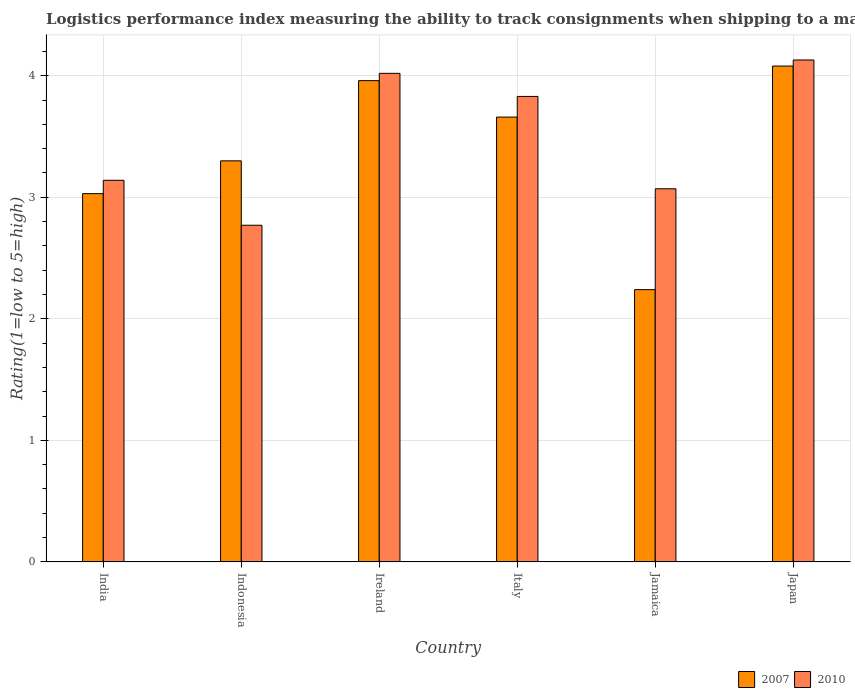How many groups of bars are there?
Keep it short and to the point. 6. What is the label of the 3rd group of bars from the left?
Your response must be concise. Ireland. In how many cases, is the number of bars for a given country not equal to the number of legend labels?
Offer a terse response. 0. What is the Logistic performance index in 2010 in Indonesia?
Keep it short and to the point. 2.77. Across all countries, what is the maximum Logistic performance index in 2007?
Give a very brief answer. 4.08. Across all countries, what is the minimum Logistic performance index in 2010?
Your response must be concise. 2.77. In which country was the Logistic performance index in 2010 minimum?
Make the answer very short. Indonesia. What is the total Logistic performance index in 2007 in the graph?
Ensure brevity in your answer.  20.27. What is the difference between the Logistic performance index in 2010 in Ireland and that in Jamaica?
Provide a short and direct response. 0.95. What is the difference between the Logistic performance index in 2007 in India and the Logistic performance index in 2010 in Japan?
Give a very brief answer. -1.1. What is the average Logistic performance index in 2007 per country?
Make the answer very short. 3.38. What is the difference between the Logistic performance index of/in 2007 and Logistic performance index of/in 2010 in Jamaica?
Your answer should be very brief. -0.83. What is the ratio of the Logistic performance index in 2010 in Italy to that in Jamaica?
Give a very brief answer. 1.25. What is the difference between the highest and the second highest Logistic performance index in 2007?
Your answer should be very brief. -0.3. What is the difference between the highest and the lowest Logistic performance index in 2007?
Make the answer very short. 1.84. In how many countries, is the Logistic performance index in 2010 greater than the average Logistic performance index in 2010 taken over all countries?
Make the answer very short. 3. Is the sum of the Logistic performance index in 2007 in Italy and Japan greater than the maximum Logistic performance index in 2010 across all countries?
Your answer should be compact. Yes. What does the 1st bar from the right in Jamaica represents?
Your answer should be compact. 2010. What is the difference between two consecutive major ticks on the Y-axis?
Your answer should be compact. 1. How many legend labels are there?
Your answer should be compact. 2. How are the legend labels stacked?
Keep it short and to the point. Horizontal. What is the title of the graph?
Make the answer very short. Logistics performance index measuring the ability to track consignments when shipping to a market. Does "1967" appear as one of the legend labels in the graph?
Your answer should be compact. No. What is the label or title of the X-axis?
Make the answer very short. Country. What is the label or title of the Y-axis?
Your response must be concise. Rating(1=low to 5=high). What is the Rating(1=low to 5=high) in 2007 in India?
Provide a short and direct response. 3.03. What is the Rating(1=low to 5=high) in 2010 in India?
Provide a short and direct response. 3.14. What is the Rating(1=low to 5=high) of 2007 in Indonesia?
Your answer should be very brief. 3.3. What is the Rating(1=low to 5=high) in 2010 in Indonesia?
Your answer should be very brief. 2.77. What is the Rating(1=low to 5=high) of 2007 in Ireland?
Offer a very short reply. 3.96. What is the Rating(1=low to 5=high) of 2010 in Ireland?
Your answer should be very brief. 4.02. What is the Rating(1=low to 5=high) in 2007 in Italy?
Ensure brevity in your answer.  3.66. What is the Rating(1=low to 5=high) of 2010 in Italy?
Offer a very short reply. 3.83. What is the Rating(1=low to 5=high) of 2007 in Jamaica?
Keep it short and to the point. 2.24. What is the Rating(1=low to 5=high) in 2010 in Jamaica?
Keep it short and to the point. 3.07. What is the Rating(1=low to 5=high) of 2007 in Japan?
Ensure brevity in your answer.  4.08. What is the Rating(1=low to 5=high) of 2010 in Japan?
Offer a terse response. 4.13. Across all countries, what is the maximum Rating(1=low to 5=high) in 2007?
Provide a succinct answer. 4.08. Across all countries, what is the maximum Rating(1=low to 5=high) of 2010?
Make the answer very short. 4.13. Across all countries, what is the minimum Rating(1=low to 5=high) in 2007?
Offer a very short reply. 2.24. Across all countries, what is the minimum Rating(1=low to 5=high) of 2010?
Your answer should be compact. 2.77. What is the total Rating(1=low to 5=high) of 2007 in the graph?
Ensure brevity in your answer.  20.27. What is the total Rating(1=low to 5=high) in 2010 in the graph?
Your answer should be compact. 20.96. What is the difference between the Rating(1=low to 5=high) of 2007 in India and that in Indonesia?
Ensure brevity in your answer.  -0.27. What is the difference between the Rating(1=low to 5=high) in 2010 in India and that in Indonesia?
Provide a short and direct response. 0.37. What is the difference between the Rating(1=low to 5=high) in 2007 in India and that in Ireland?
Ensure brevity in your answer.  -0.93. What is the difference between the Rating(1=low to 5=high) in 2010 in India and that in Ireland?
Give a very brief answer. -0.88. What is the difference between the Rating(1=low to 5=high) in 2007 in India and that in Italy?
Keep it short and to the point. -0.63. What is the difference between the Rating(1=low to 5=high) in 2010 in India and that in Italy?
Ensure brevity in your answer.  -0.69. What is the difference between the Rating(1=low to 5=high) of 2007 in India and that in Jamaica?
Offer a very short reply. 0.79. What is the difference between the Rating(1=low to 5=high) of 2010 in India and that in Jamaica?
Keep it short and to the point. 0.07. What is the difference between the Rating(1=low to 5=high) in 2007 in India and that in Japan?
Provide a short and direct response. -1.05. What is the difference between the Rating(1=low to 5=high) in 2010 in India and that in Japan?
Your answer should be compact. -0.99. What is the difference between the Rating(1=low to 5=high) of 2007 in Indonesia and that in Ireland?
Your answer should be very brief. -0.66. What is the difference between the Rating(1=low to 5=high) of 2010 in Indonesia and that in Ireland?
Make the answer very short. -1.25. What is the difference between the Rating(1=low to 5=high) of 2007 in Indonesia and that in Italy?
Your answer should be very brief. -0.36. What is the difference between the Rating(1=low to 5=high) of 2010 in Indonesia and that in Italy?
Your answer should be compact. -1.06. What is the difference between the Rating(1=low to 5=high) in 2007 in Indonesia and that in Jamaica?
Make the answer very short. 1.06. What is the difference between the Rating(1=low to 5=high) of 2010 in Indonesia and that in Jamaica?
Provide a short and direct response. -0.3. What is the difference between the Rating(1=low to 5=high) of 2007 in Indonesia and that in Japan?
Ensure brevity in your answer.  -0.78. What is the difference between the Rating(1=low to 5=high) of 2010 in Indonesia and that in Japan?
Provide a succinct answer. -1.36. What is the difference between the Rating(1=low to 5=high) of 2010 in Ireland and that in Italy?
Your response must be concise. 0.19. What is the difference between the Rating(1=low to 5=high) of 2007 in Ireland and that in Jamaica?
Make the answer very short. 1.72. What is the difference between the Rating(1=low to 5=high) of 2010 in Ireland and that in Jamaica?
Ensure brevity in your answer.  0.95. What is the difference between the Rating(1=low to 5=high) in 2007 in Ireland and that in Japan?
Your response must be concise. -0.12. What is the difference between the Rating(1=low to 5=high) of 2010 in Ireland and that in Japan?
Your answer should be compact. -0.11. What is the difference between the Rating(1=low to 5=high) in 2007 in Italy and that in Jamaica?
Make the answer very short. 1.42. What is the difference between the Rating(1=low to 5=high) in 2010 in Italy and that in Jamaica?
Give a very brief answer. 0.76. What is the difference between the Rating(1=low to 5=high) of 2007 in Italy and that in Japan?
Your answer should be very brief. -0.42. What is the difference between the Rating(1=low to 5=high) in 2007 in Jamaica and that in Japan?
Give a very brief answer. -1.84. What is the difference between the Rating(1=low to 5=high) in 2010 in Jamaica and that in Japan?
Ensure brevity in your answer.  -1.06. What is the difference between the Rating(1=low to 5=high) of 2007 in India and the Rating(1=low to 5=high) of 2010 in Indonesia?
Give a very brief answer. 0.26. What is the difference between the Rating(1=low to 5=high) in 2007 in India and the Rating(1=low to 5=high) in 2010 in Ireland?
Keep it short and to the point. -0.99. What is the difference between the Rating(1=low to 5=high) in 2007 in India and the Rating(1=low to 5=high) in 2010 in Italy?
Your answer should be compact. -0.8. What is the difference between the Rating(1=low to 5=high) in 2007 in India and the Rating(1=low to 5=high) in 2010 in Jamaica?
Offer a very short reply. -0.04. What is the difference between the Rating(1=low to 5=high) in 2007 in India and the Rating(1=low to 5=high) in 2010 in Japan?
Provide a short and direct response. -1.1. What is the difference between the Rating(1=low to 5=high) of 2007 in Indonesia and the Rating(1=low to 5=high) of 2010 in Ireland?
Keep it short and to the point. -0.72. What is the difference between the Rating(1=low to 5=high) of 2007 in Indonesia and the Rating(1=low to 5=high) of 2010 in Italy?
Make the answer very short. -0.53. What is the difference between the Rating(1=low to 5=high) in 2007 in Indonesia and the Rating(1=low to 5=high) in 2010 in Jamaica?
Provide a short and direct response. 0.23. What is the difference between the Rating(1=low to 5=high) in 2007 in Indonesia and the Rating(1=low to 5=high) in 2010 in Japan?
Keep it short and to the point. -0.83. What is the difference between the Rating(1=low to 5=high) of 2007 in Ireland and the Rating(1=low to 5=high) of 2010 in Italy?
Your answer should be very brief. 0.13. What is the difference between the Rating(1=low to 5=high) in 2007 in Ireland and the Rating(1=low to 5=high) in 2010 in Jamaica?
Your answer should be compact. 0.89. What is the difference between the Rating(1=low to 5=high) of 2007 in Ireland and the Rating(1=low to 5=high) of 2010 in Japan?
Your answer should be very brief. -0.17. What is the difference between the Rating(1=low to 5=high) in 2007 in Italy and the Rating(1=low to 5=high) in 2010 in Jamaica?
Give a very brief answer. 0.59. What is the difference between the Rating(1=low to 5=high) in 2007 in Italy and the Rating(1=low to 5=high) in 2010 in Japan?
Offer a very short reply. -0.47. What is the difference between the Rating(1=low to 5=high) of 2007 in Jamaica and the Rating(1=low to 5=high) of 2010 in Japan?
Give a very brief answer. -1.89. What is the average Rating(1=low to 5=high) in 2007 per country?
Your response must be concise. 3.38. What is the average Rating(1=low to 5=high) of 2010 per country?
Ensure brevity in your answer.  3.49. What is the difference between the Rating(1=low to 5=high) in 2007 and Rating(1=low to 5=high) in 2010 in India?
Provide a succinct answer. -0.11. What is the difference between the Rating(1=low to 5=high) in 2007 and Rating(1=low to 5=high) in 2010 in Indonesia?
Ensure brevity in your answer.  0.53. What is the difference between the Rating(1=low to 5=high) of 2007 and Rating(1=low to 5=high) of 2010 in Ireland?
Keep it short and to the point. -0.06. What is the difference between the Rating(1=low to 5=high) of 2007 and Rating(1=low to 5=high) of 2010 in Italy?
Provide a short and direct response. -0.17. What is the difference between the Rating(1=low to 5=high) in 2007 and Rating(1=low to 5=high) in 2010 in Jamaica?
Your response must be concise. -0.83. What is the difference between the Rating(1=low to 5=high) in 2007 and Rating(1=low to 5=high) in 2010 in Japan?
Provide a short and direct response. -0.05. What is the ratio of the Rating(1=low to 5=high) of 2007 in India to that in Indonesia?
Your answer should be very brief. 0.92. What is the ratio of the Rating(1=low to 5=high) in 2010 in India to that in Indonesia?
Offer a very short reply. 1.13. What is the ratio of the Rating(1=low to 5=high) of 2007 in India to that in Ireland?
Provide a succinct answer. 0.77. What is the ratio of the Rating(1=low to 5=high) in 2010 in India to that in Ireland?
Your answer should be very brief. 0.78. What is the ratio of the Rating(1=low to 5=high) in 2007 in India to that in Italy?
Your response must be concise. 0.83. What is the ratio of the Rating(1=low to 5=high) in 2010 in India to that in Italy?
Your answer should be very brief. 0.82. What is the ratio of the Rating(1=low to 5=high) of 2007 in India to that in Jamaica?
Offer a very short reply. 1.35. What is the ratio of the Rating(1=low to 5=high) of 2010 in India to that in Jamaica?
Your answer should be very brief. 1.02. What is the ratio of the Rating(1=low to 5=high) in 2007 in India to that in Japan?
Make the answer very short. 0.74. What is the ratio of the Rating(1=low to 5=high) of 2010 in India to that in Japan?
Ensure brevity in your answer.  0.76. What is the ratio of the Rating(1=low to 5=high) in 2010 in Indonesia to that in Ireland?
Give a very brief answer. 0.69. What is the ratio of the Rating(1=low to 5=high) in 2007 in Indonesia to that in Italy?
Provide a succinct answer. 0.9. What is the ratio of the Rating(1=low to 5=high) of 2010 in Indonesia to that in Italy?
Ensure brevity in your answer.  0.72. What is the ratio of the Rating(1=low to 5=high) of 2007 in Indonesia to that in Jamaica?
Offer a terse response. 1.47. What is the ratio of the Rating(1=low to 5=high) of 2010 in Indonesia to that in Jamaica?
Offer a very short reply. 0.9. What is the ratio of the Rating(1=low to 5=high) of 2007 in Indonesia to that in Japan?
Provide a short and direct response. 0.81. What is the ratio of the Rating(1=low to 5=high) in 2010 in Indonesia to that in Japan?
Ensure brevity in your answer.  0.67. What is the ratio of the Rating(1=low to 5=high) in 2007 in Ireland to that in Italy?
Keep it short and to the point. 1.08. What is the ratio of the Rating(1=low to 5=high) in 2010 in Ireland to that in Italy?
Your response must be concise. 1.05. What is the ratio of the Rating(1=low to 5=high) in 2007 in Ireland to that in Jamaica?
Ensure brevity in your answer.  1.77. What is the ratio of the Rating(1=low to 5=high) in 2010 in Ireland to that in Jamaica?
Keep it short and to the point. 1.31. What is the ratio of the Rating(1=low to 5=high) of 2007 in Ireland to that in Japan?
Give a very brief answer. 0.97. What is the ratio of the Rating(1=low to 5=high) of 2010 in Ireland to that in Japan?
Give a very brief answer. 0.97. What is the ratio of the Rating(1=low to 5=high) in 2007 in Italy to that in Jamaica?
Keep it short and to the point. 1.63. What is the ratio of the Rating(1=low to 5=high) of 2010 in Italy to that in Jamaica?
Keep it short and to the point. 1.25. What is the ratio of the Rating(1=low to 5=high) of 2007 in Italy to that in Japan?
Offer a terse response. 0.9. What is the ratio of the Rating(1=low to 5=high) of 2010 in Italy to that in Japan?
Provide a short and direct response. 0.93. What is the ratio of the Rating(1=low to 5=high) in 2007 in Jamaica to that in Japan?
Your answer should be compact. 0.55. What is the ratio of the Rating(1=low to 5=high) of 2010 in Jamaica to that in Japan?
Your answer should be very brief. 0.74. What is the difference between the highest and the second highest Rating(1=low to 5=high) of 2007?
Offer a terse response. 0.12. What is the difference between the highest and the second highest Rating(1=low to 5=high) in 2010?
Provide a succinct answer. 0.11. What is the difference between the highest and the lowest Rating(1=low to 5=high) in 2007?
Offer a very short reply. 1.84. What is the difference between the highest and the lowest Rating(1=low to 5=high) in 2010?
Provide a succinct answer. 1.36. 